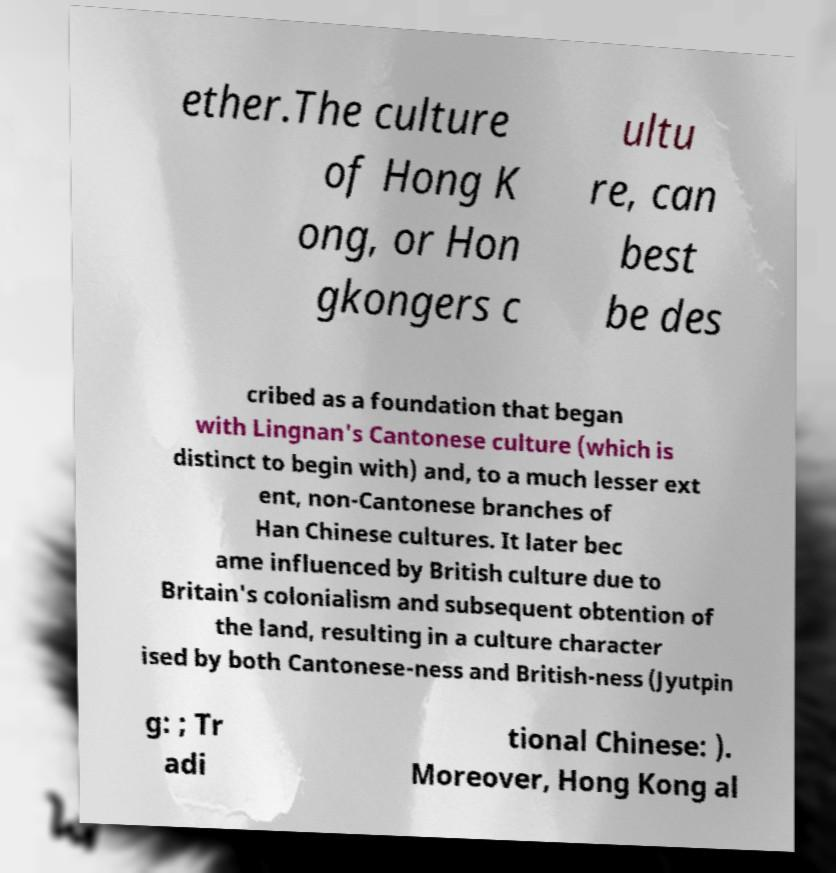Can you read and provide the text displayed in the image?This photo seems to have some interesting text. Can you extract and type it out for me? ether.The culture of Hong K ong, or Hon gkongers c ultu re, can best be des cribed as a foundation that began with Lingnan's Cantonese culture (which is distinct to begin with) and, to a much lesser ext ent, non-Cantonese branches of Han Chinese cultures. It later bec ame influenced by British culture due to Britain's colonialism and subsequent obtention of the land, resulting in a culture character ised by both Cantonese-ness and British-ness (Jyutpin g: ; Tr adi tional Chinese: ). Moreover, Hong Kong al 